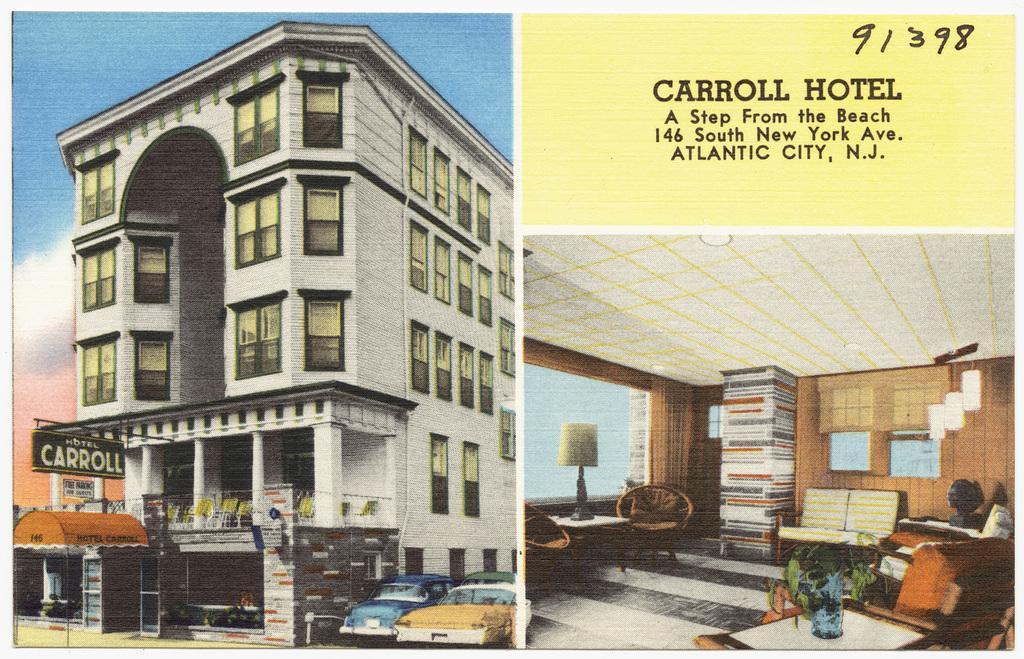How would you summarize this image in a sentence or two? In this picture we can see the images on the paper and in the images there is a building, a board and vehicles. Behind the building there is the sky. In the other image we can see the inside view of a building and in the building there are chairs, a lamp, table, couch and a wall. At the top there are ceiling lights. 